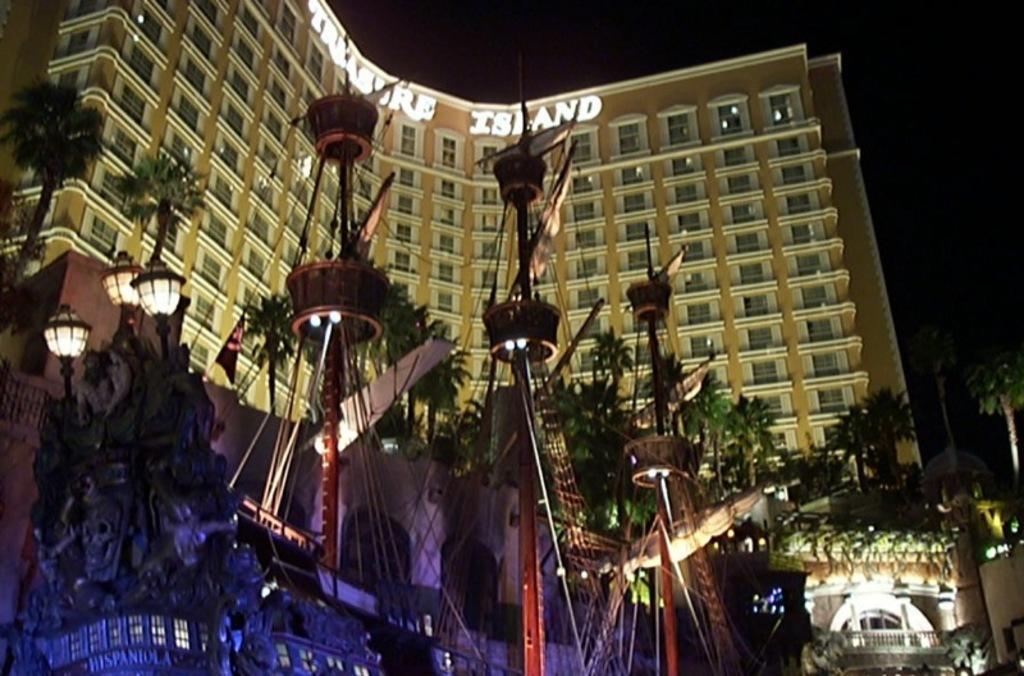How would you summarize this image in a sentence or two? In this image we can see the building, there is a ship, trees, plants, there is a board with text on it, also the background is dark. 